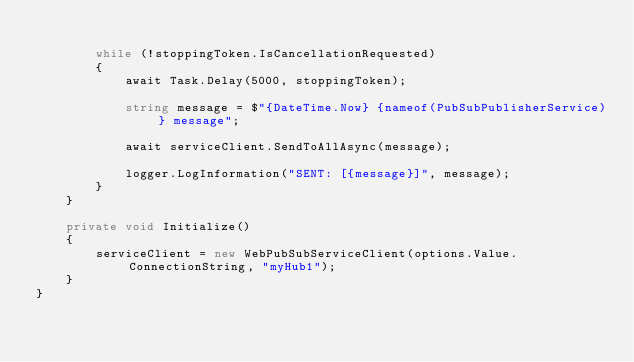Convert code to text. <code><loc_0><loc_0><loc_500><loc_500><_C#_>
        while (!stoppingToken.IsCancellationRequested)
        {
            await Task.Delay(5000, stoppingToken);

            string message = $"{DateTime.Now} {nameof(PubSubPublisherService)} message";

            await serviceClient.SendToAllAsync(message);

            logger.LogInformation("SENT: [{message}]", message);
        }
    }

    private void Initialize()
    {
        serviceClient = new WebPubSubServiceClient(options.Value.ConnectionString, "myHub1");
    }
}</code> 